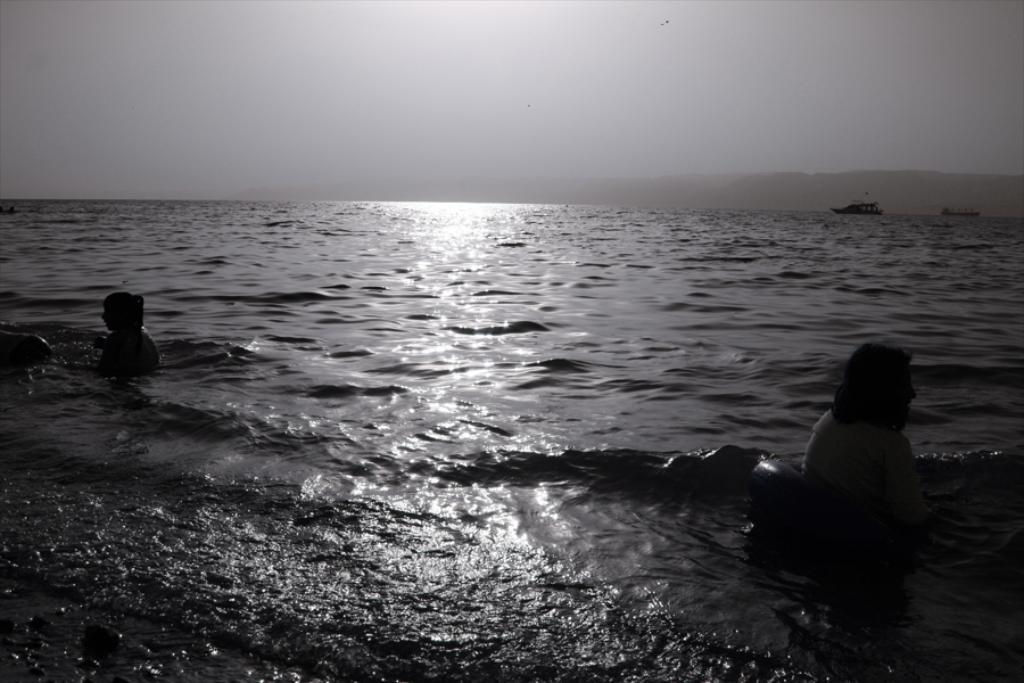What are the two people in the image doing? The two people in the image are swimming in the water. What can be seen in the background of the image? In the background, there are ships floating on the water and hills visible. What is visible in the sky in the image? The sky is visible in the background of the image. What type of pan can be seen being used by the swimmers in the image? There is no pan present in the image; the two people are swimming in the water. 